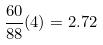Convert formula to latex. <formula><loc_0><loc_0><loc_500><loc_500>\frac { 6 0 } { 8 8 } ( 4 ) = 2 . 7 2</formula> 